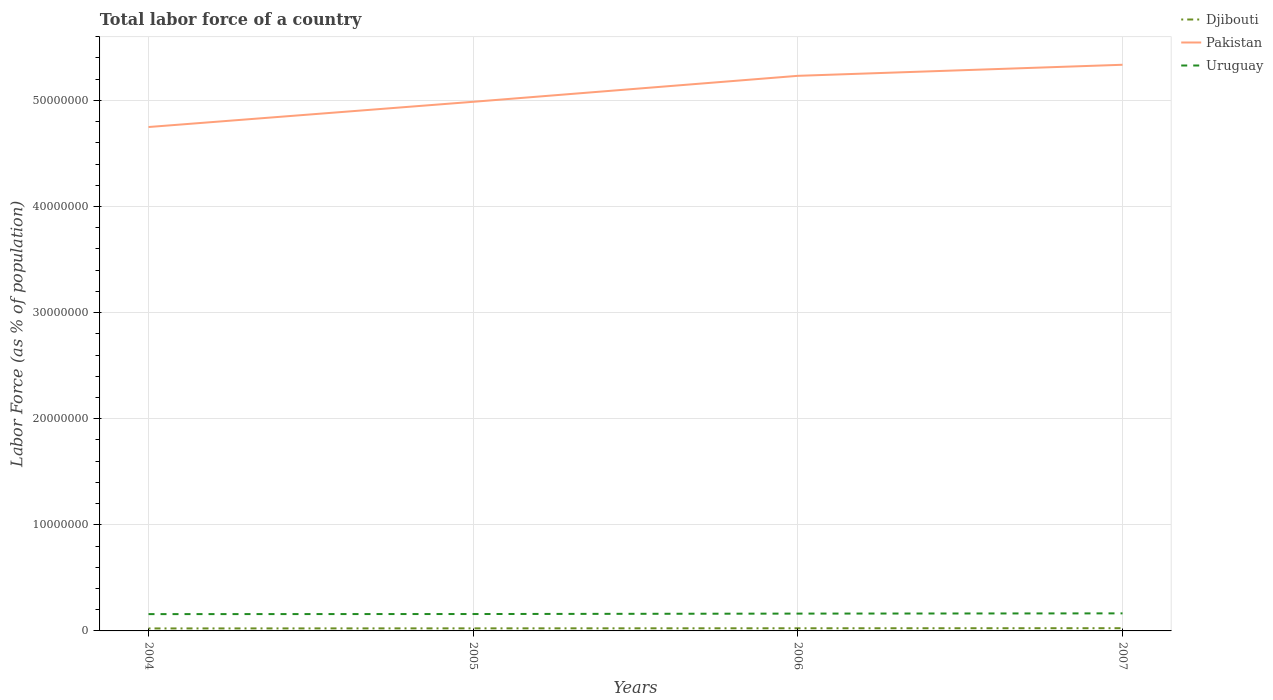Is the number of lines equal to the number of legend labels?
Give a very brief answer. Yes. Across all years, what is the maximum percentage of labor force in Uruguay?
Provide a succinct answer. 1.58e+06. What is the total percentage of labor force in Uruguay in the graph?
Give a very brief answer. -6.30e+04. What is the difference between the highest and the second highest percentage of labor force in Djibouti?
Your answer should be very brief. 2.21e+04. How many lines are there?
Offer a very short reply. 3. What is the difference between two consecutive major ticks on the Y-axis?
Make the answer very short. 1.00e+07. Are the values on the major ticks of Y-axis written in scientific E-notation?
Offer a terse response. No. What is the title of the graph?
Provide a succinct answer. Total labor force of a country. What is the label or title of the Y-axis?
Offer a terse response. Labor Force (as % of population). What is the Labor Force (as % of population) of Djibouti in 2004?
Give a very brief answer. 2.34e+05. What is the Labor Force (as % of population) in Pakistan in 2004?
Provide a succinct answer. 4.75e+07. What is the Labor Force (as % of population) of Uruguay in 2004?
Keep it short and to the point. 1.58e+06. What is the Labor Force (as % of population) of Djibouti in 2005?
Your response must be concise. 2.41e+05. What is the Labor Force (as % of population) of Pakistan in 2005?
Ensure brevity in your answer.  4.99e+07. What is the Labor Force (as % of population) of Uruguay in 2005?
Your answer should be very brief. 1.59e+06. What is the Labor Force (as % of population) in Djibouti in 2006?
Your response must be concise. 2.49e+05. What is the Labor Force (as % of population) in Pakistan in 2006?
Make the answer very short. 5.23e+07. What is the Labor Force (as % of population) in Uruguay in 2006?
Provide a short and direct response. 1.63e+06. What is the Labor Force (as % of population) of Djibouti in 2007?
Ensure brevity in your answer.  2.56e+05. What is the Labor Force (as % of population) in Pakistan in 2007?
Make the answer very short. 5.34e+07. What is the Labor Force (as % of population) in Uruguay in 2007?
Your answer should be very brief. 1.65e+06. Across all years, what is the maximum Labor Force (as % of population) in Djibouti?
Make the answer very short. 2.56e+05. Across all years, what is the maximum Labor Force (as % of population) in Pakistan?
Give a very brief answer. 5.34e+07. Across all years, what is the maximum Labor Force (as % of population) in Uruguay?
Your answer should be compact. 1.65e+06. Across all years, what is the minimum Labor Force (as % of population) of Djibouti?
Your response must be concise. 2.34e+05. Across all years, what is the minimum Labor Force (as % of population) in Pakistan?
Provide a short and direct response. 4.75e+07. Across all years, what is the minimum Labor Force (as % of population) of Uruguay?
Your answer should be compact. 1.58e+06. What is the total Labor Force (as % of population) of Djibouti in the graph?
Provide a short and direct response. 9.80e+05. What is the total Labor Force (as % of population) of Pakistan in the graph?
Your response must be concise. 2.03e+08. What is the total Labor Force (as % of population) in Uruguay in the graph?
Keep it short and to the point. 6.46e+06. What is the difference between the Labor Force (as % of population) of Djibouti in 2004 and that in 2005?
Offer a terse response. -7474. What is the difference between the Labor Force (as % of population) of Pakistan in 2004 and that in 2005?
Make the answer very short. -2.38e+06. What is the difference between the Labor Force (as % of population) in Uruguay in 2004 and that in 2005?
Provide a succinct answer. -7301. What is the difference between the Labor Force (as % of population) in Djibouti in 2004 and that in 2006?
Offer a very short reply. -1.49e+04. What is the difference between the Labor Force (as % of population) of Pakistan in 2004 and that in 2006?
Offer a terse response. -4.82e+06. What is the difference between the Labor Force (as % of population) of Uruguay in 2004 and that in 2006?
Offer a terse response. -4.78e+04. What is the difference between the Labor Force (as % of population) in Djibouti in 2004 and that in 2007?
Keep it short and to the point. -2.21e+04. What is the difference between the Labor Force (as % of population) in Pakistan in 2004 and that in 2007?
Offer a very short reply. -5.87e+06. What is the difference between the Labor Force (as % of population) of Uruguay in 2004 and that in 2007?
Offer a very short reply. -7.03e+04. What is the difference between the Labor Force (as % of population) of Djibouti in 2005 and that in 2006?
Provide a short and direct response. -7453. What is the difference between the Labor Force (as % of population) of Pakistan in 2005 and that in 2006?
Make the answer very short. -2.45e+06. What is the difference between the Labor Force (as % of population) in Uruguay in 2005 and that in 2006?
Provide a succinct answer. -4.05e+04. What is the difference between the Labor Force (as % of population) of Djibouti in 2005 and that in 2007?
Your answer should be very brief. -1.46e+04. What is the difference between the Labor Force (as % of population) of Pakistan in 2005 and that in 2007?
Your answer should be compact. -3.49e+06. What is the difference between the Labor Force (as % of population) in Uruguay in 2005 and that in 2007?
Give a very brief answer. -6.30e+04. What is the difference between the Labor Force (as % of population) of Djibouti in 2006 and that in 2007?
Your answer should be compact. -7183. What is the difference between the Labor Force (as % of population) of Pakistan in 2006 and that in 2007?
Ensure brevity in your answer.  -1.04e+06. What is the difference between the Labor Force (as % of population) of Uruguay in 2006 and that in 2007?
Provide a short and direct response. -2.25e+04. What is the difference between the Labor Force (as % of population) of Djibouti in 2004 and the Labor Force (as % of population) of Pakistan in 2005?
Ensure brevity in your answer.  -4.96e+07. What is the difference between the Labor Force (as % of population) of Djibouti in 2004 and the Labor Force (as % of population) of Uruguay in 2005?
Your answer should be very brief. -1.36e+06. What is the difference between the Labor Force (as % of population) in Pakistan in 2004 and the Labor Force (as % of population) in Uruguay in 2005?
Provide a short and direct response. 4.59e+07. What is the difference between the Labor Force (as % of population) of Djibouti in 2004 and the Labor Force (as % of population) of Pakistan in 2006?
Provide a short and direct response. -5.21e+07. What is the difference between the Labor Force (as % of population) in Djibouti in 2004 and the Labor Force (as % of population) in Uruguay in 2006?
Provide a succinct answer. -1.40e+06. What is the difference between the Labor Force (as % of population) in Pakistan in 2004 and the Labor Force (as % of population) in Uruguay in 2006?
Your answer should be very brief. 4.59e+07. What is the difference between the Labor Force (as % of population) of Djibouti in 2004 and the Labor Force (as % of population) of Pakistan in 2007?
Provide a short and direct response. -5.31e+07. What is the difference between the Labor Force (as % of population) in Djibouti in 2004 and the Labor Force (as % of population) in Uruguay in 2007?
Keep it short and to the point. -1.42e+06. What is the difference between the Labor Force (as % of population) in Pakistan in 2004 and the Labor Force (as % of population) in Uruguay in 2007?
Keep it short and to the point. 4.58e+07. What is the difference between the Labor Force (as % of population) in Djibouti in 2005 and the Labor Force (as % of population) in Pakistan in 2006?
Your response must be concise. -5.21e+07. What is the difference between the Labor Force (as % of population) of Djibouti in 2005 and the Labor Force (as % of population) of Uruguay in 2006?
Your answer should be very brief. -1.39e+06. What is the difference between the Labor Force (as % of population) of Pakistan in 2005 and the Labor Force (as % of population) of Uruguay in 2006?
Keep it short and to the point. 4.82e+07. What is the difference between the Labor Force (as % of population) in Djibouti in 2005 and the Labor Force (as % of population) in Pakistan in 2007?
Ensure brevity in your answer.  -5.31e+07. What is the difference between the Labor Force (as % of population) of Djibouti in 2005 and the Labor Force (as % of population) of Uruguay in 2007?
Give a very brief answer. -1.41e+06. What is the difference between the Labor Force (as % of population) of Pakistan in 2005 and the Labor Force (as % of population) of Uruguay in 2007?
Your answer should be compact. 4.82e+07. What is the difference between the Labor Force (as % of population) in Djibouti in 2006 and the Labor Force (as % of population) in Pakistan in 2007?
Your response must be concise. -5.31e+07. What is the difference between the Labor Force (as % of population) of Djibouti in 2006 and the Labor Force (as % of population) of Uruguay in 2007?
Provide a short and direct response. -1.41e+06. What is the difference between the Labor Force (as % of population) of Pakistan in 2006 and the Labor Force (as % of population) of Uruguay in 2007?
Keep it short and to the point. 5.07e+07. What is the average Labor Force (as % of population) in Djibouti per year?
Your answer should be compact. 2.45e+05. What is the average Labor Force (as % of population) in Pakistan per year?
Offer a terse response. 5.08e+07. What is the average Labor Force (as % of population) in Uruguay per year?
Make the answer very short. 1.62e+06. In the year 2004, what is the difference between the Labor Force (as % of population) in Djibouti and Labor Force (as % of population) in Pakistan?
Give a very brief answer. -4.73e+07. In the year 2004, what is the difference between the Labor Force (as % of population) of Djibouti and Labor Force (as % of population) of Uruguay?
Give a very brief answer. -1.35e+06. In the year 2004, what is the difference between the Labor Force (as % of population) in Pakistan and Labor Force (as % of population) in Uruguay?
Your answer should be very brief. 4.59e+07. In the year 2005, what is the difference between the Labor Force (as % of population) of Djibouti and Labor Force (as % of population) of Pakistan?
Ensure brevity in your answer.  -4.96e+07. In the year 2005, what is the difference between the Labor Force (as % of population) of Djibouti and Labor Force (as % of population) of Uruguay?
Ensure brevity in your answer.  -1.35e+06. In the year 2005, what is the difference between the Labor Force (as % of population) in Pakistan and Labor Force (as % of population) in Uruguay?
Your response must be concise. 4.83e+07. In the year 2006, what is the difference between the Labor Force (as % of population) in Djibouti and Labor Force (as % of population) in Pakistan?
Your answer should be very brief. -5.21e+07. In the year 2006, what is the difference between the Labor Force (as % of population) of Djibouti and Labor Force (as % of population) of Uruguay?
Give a very brief answer. -1.38e+06. In the year 2006, what is the difference between the Labor Force (as % of population) in Pakistan and Labor Force (as % of population) in Uruguay?
Offer a terse response. 5.07e+07. In the year 2007, what is the difference between the Labor Force (as % of population) in Djibouti and Labor Force (as % of population) in Pakistan?
Provide a succinct answer. -5.31e+07. In the year 2007, what is the difference between the Labor Force (as % of population) of Djibouti and Labor Force (as % of population) of Uruguay?
Your answer should be compact. -1.40e+06. In the year 2007, what is the difference between the Labor Force (as % of population) of Pakistan and Labor Force (as % of population) of Uruguay?
Your answer should be compact. 5.17e+07. What is the ratio of the Labor Force (as % of population) of Djibouti in 2004 to that in 2005?
Make the answer very short. 0.97. What is the ratio of the Labor Force (as % of population) of Pakistan in 2004 to that in 2005?
Give a very brief answer. 0.95. What is the ratio of the Labor Force (as % of population) of Pakistan in 2004 to that in 2006?
Give a very brief answer. 0.91. What is the ratio of the Labor Force (as % of population) of Uruguay in 2004 to that in 2006?
Offer a very short reply. 0.97. What is the ratio of the Labor Force (as % of population) of Djibouti in 2004 to that in 2007?
Your answer should be compact. 0.91. What is the ratio of the Labor Force (as % of population) in Pakistan in 2004 to that in 2007?
Make the answer very short. 0.89. What is the ratio of the Labor Force (as % of population) of Uruguay in 2004 to that in 2007?
Offer a very short reply. 0.96. What is the ratio of the Labor Force (as % of population) of Djibouti in 2005 to that in 2006?
Provide a short and direct response. 0.97. What is the ratio of the Labor Force (as % of population) of Pakistan in 2005 to that in 2006?
Keep it short and to the point. 0.95. What is the ratio of the Labor Force (as % of population) in Uruguay in 2005 to that in 2006?
Offer a very short reply. 0.98. What is the ratio of the Labor Force (as % of population) in Djibouti in 2005 to that in 2007?
Keep it short and to the point. 0.94. What is the ratio of the Labor Force (as % of population) of Pakistan in 2005 to that in 2007?
Your response must be concise. 0.93. What is the ratio of the Labor Force (as % of population) in Uruguay in 2005 to that in 2007?
Give a very brief answer. 0.96. What is the ratio of the Labor Force (as % of population) in Djibouti in 2006 to that in 2007?
Offer a terse response. 0.97. What is the ratio of the Labor Force (as % of population) of Pakistan in 2006 to that in 2007?
Your response must be concise. 0.98. What is the ratio of the Labor Force (as % of population) of Uruguay in 2006 to that in 2007?
Keep it short and to the point. 0.99. What is the difference between the highest and the second highest Labor Force (as % of population) of Djibouti?
Your answer should be compact. 7183. What is the difference between the highest and the second highest Labor Force (as % of population) in Pakistan?
Make the answer very short. 1.04e+06. What is the difference between the highest and the second highest Labor Force (as % of population) in Uruguay?
Keep it short and to the point. 2.25e+04. What is the difference between the highest and the lowest Labor Force (as % of population) in Djibouti?
Make the answer very short. 2.21e+04. What is the difference between the highest and the lowest Labor Force (as % of population) of Pakistan?
Offer a very short reply. 5.87e+06. What is the difference between the highest and the lowest Labor Force (as % of population) of Uruguay?
Your answer should be compact. 7.03e+04. 